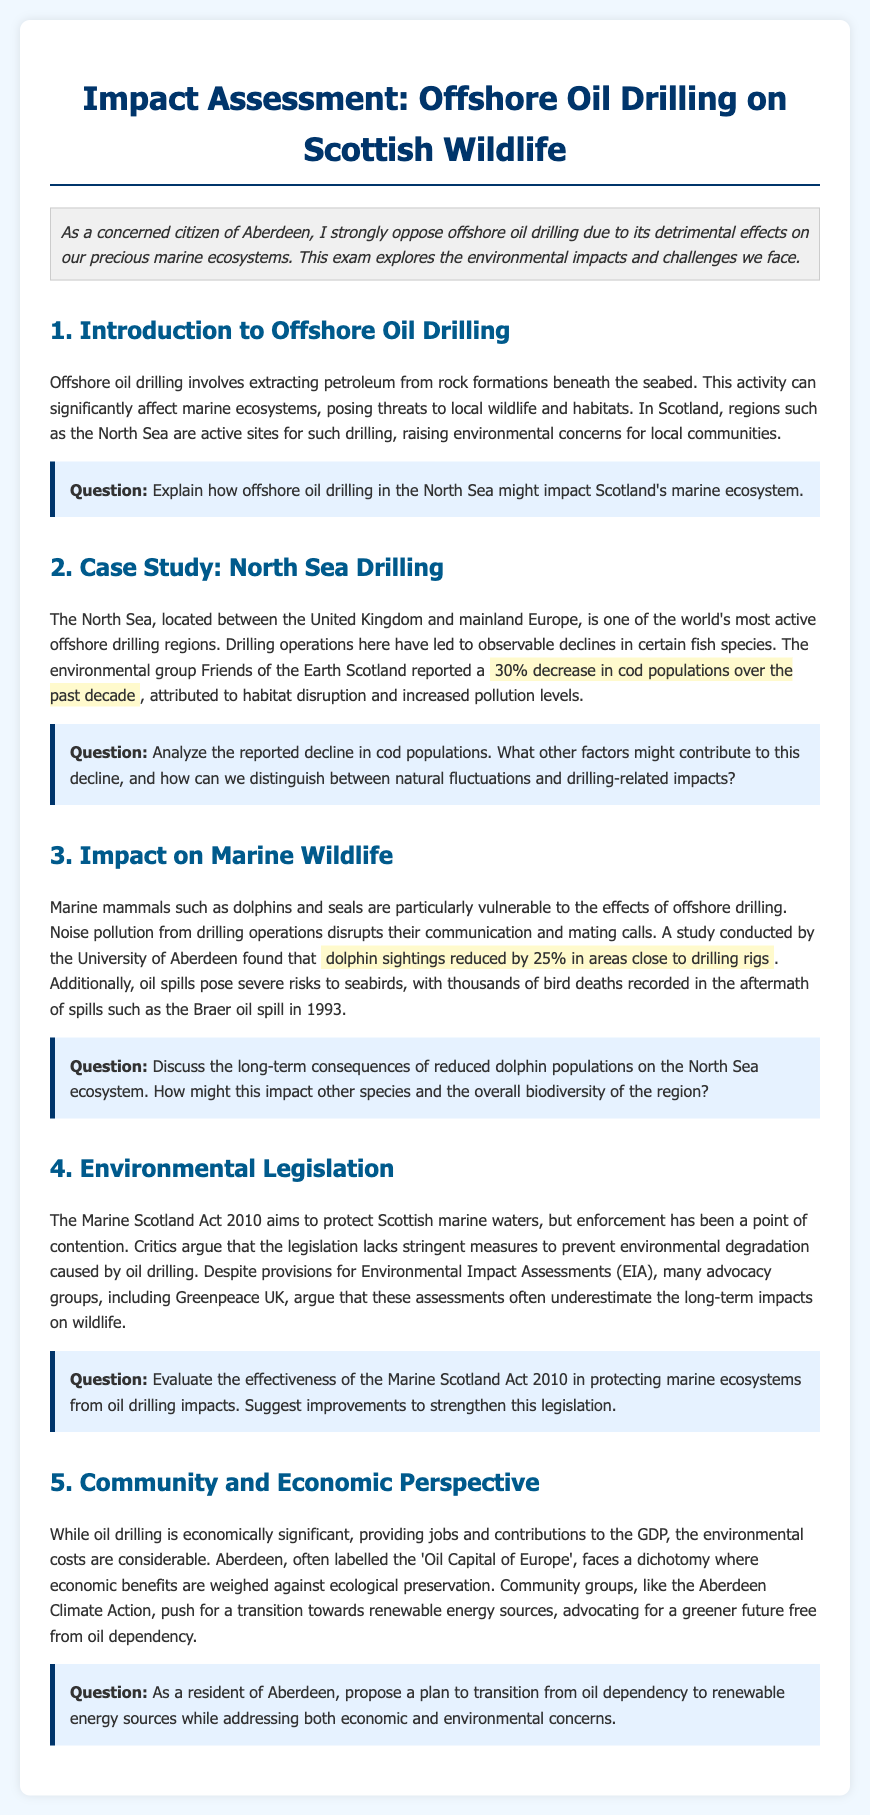What is the primary concern regarding offshore oil drilling? The primary concern is its detrimental effects on marine ecosystems as mentioned by the concerned citizen from Aberdeen.
Answer: Detimental effects on marine ecosystems What percentage decrease in cod populations has been reported? The document states that there has been a 30% decrease in cod populations over the past decade due to habitat disruption and increased pollution.
Answer: 30% What group reported the decline in cod populations? The environmental group Friends of the Earth Scotland reported the decline in cod populations.
Answer: Friends of the Earth Scotland What year did the Braer oil spill occur? The document mentions the Braer oil spill occurred in 1993, which led to thousands of bird deaths.
Answer: 1993 What is the name of the act aimed at protecting Scottish marine waters? The act aimed at protecting Scottish marine waters is called the Marine Scotland Act 2010.
Answer: Marine Scotland Act 2010 What impact does drilling noise have on marine mammals? Noise pollution from drilling operations disrupts communication and mating calls of marine mammals such as dolphins and seals.
Answer: Disrupts communication and mating calls What is the main economic mindset of Aberdeen regarding oil drilling? The document describes Aberdeen as being labelled the 'Oil Capital of Europe' with a strong investment in oil drilling despite environmental concerns.
Answer: Oil Capital of Europe What alternative energy sources do community groups advocate for? Aberdeen Climate Action advocates for a transition towards renewable energy sources as an alternative to oil dependency.
Answer: Renewable energy sources What is a significant criticism of the Environmental Impact Assessments? Many advocacy groups argue that the Environmental Impact Assessments often underestimate the long-term impacts on wildlife.
Answer: Underestimate long-term impacts on wildlife 